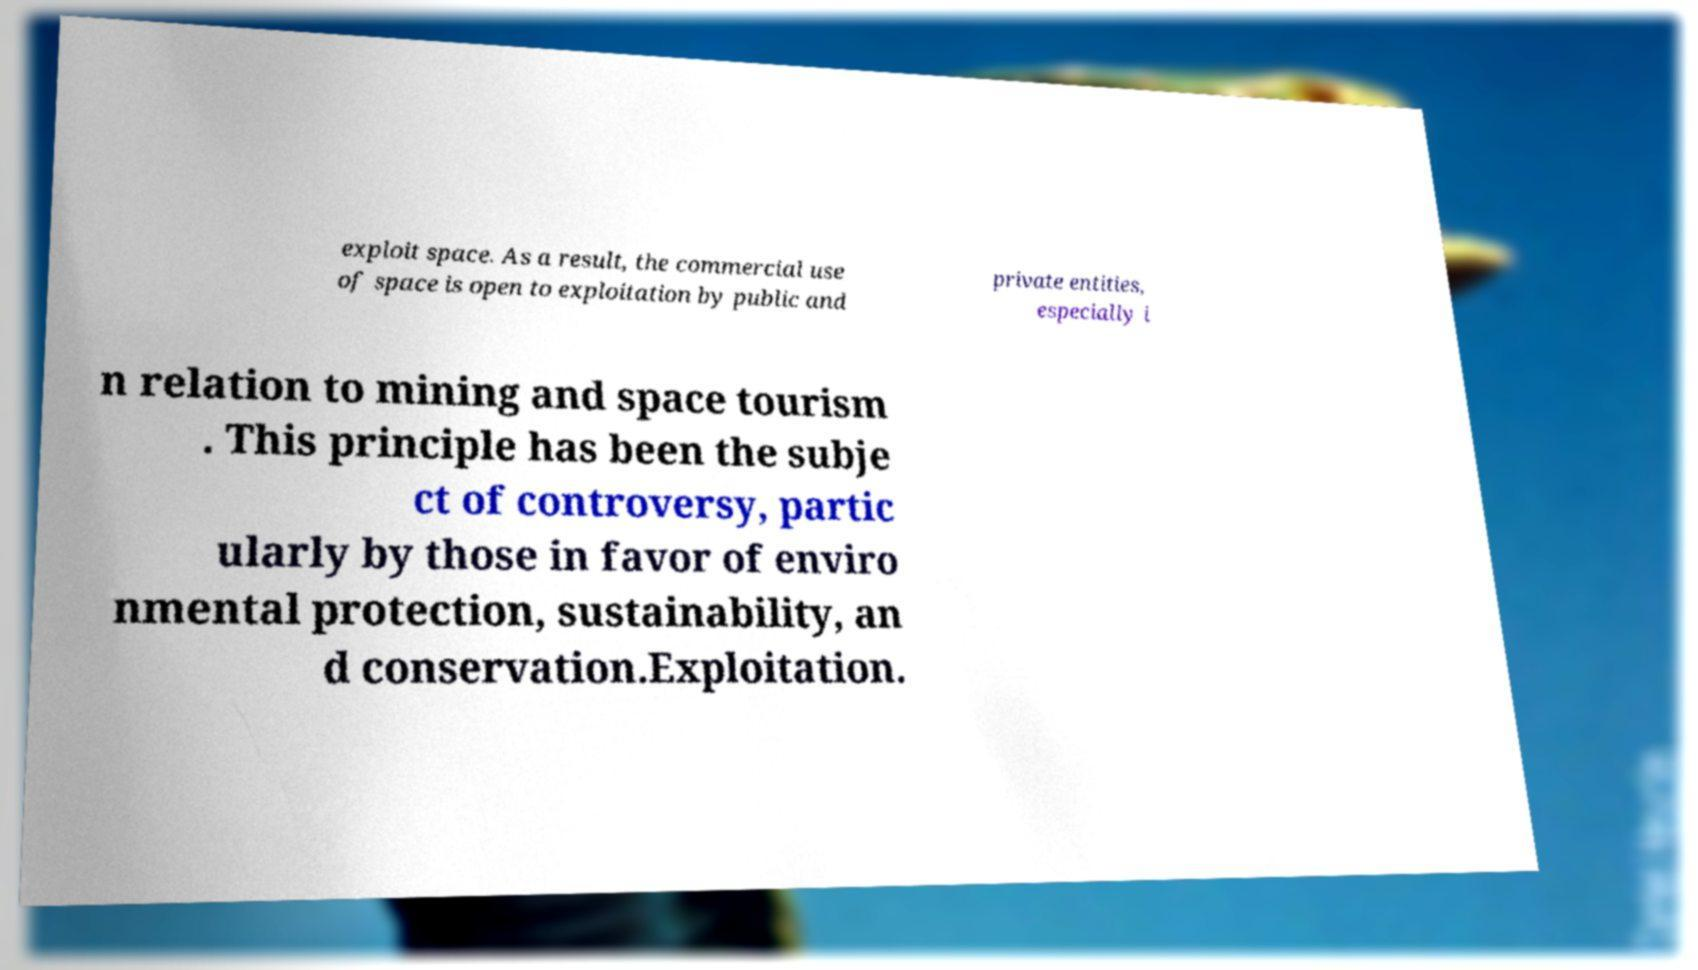Could you assist in decoding the text presented in this image and type it out clearly? exploit space. As a result, the commercial use of space is open to exploitation by public and private entities, especially i n relation to mining and space tourism . This principle has been the subje ct of controversy, partic ularly by those in favor of enviro nmental protection, sustainability, an d conservation.Exploitation. 